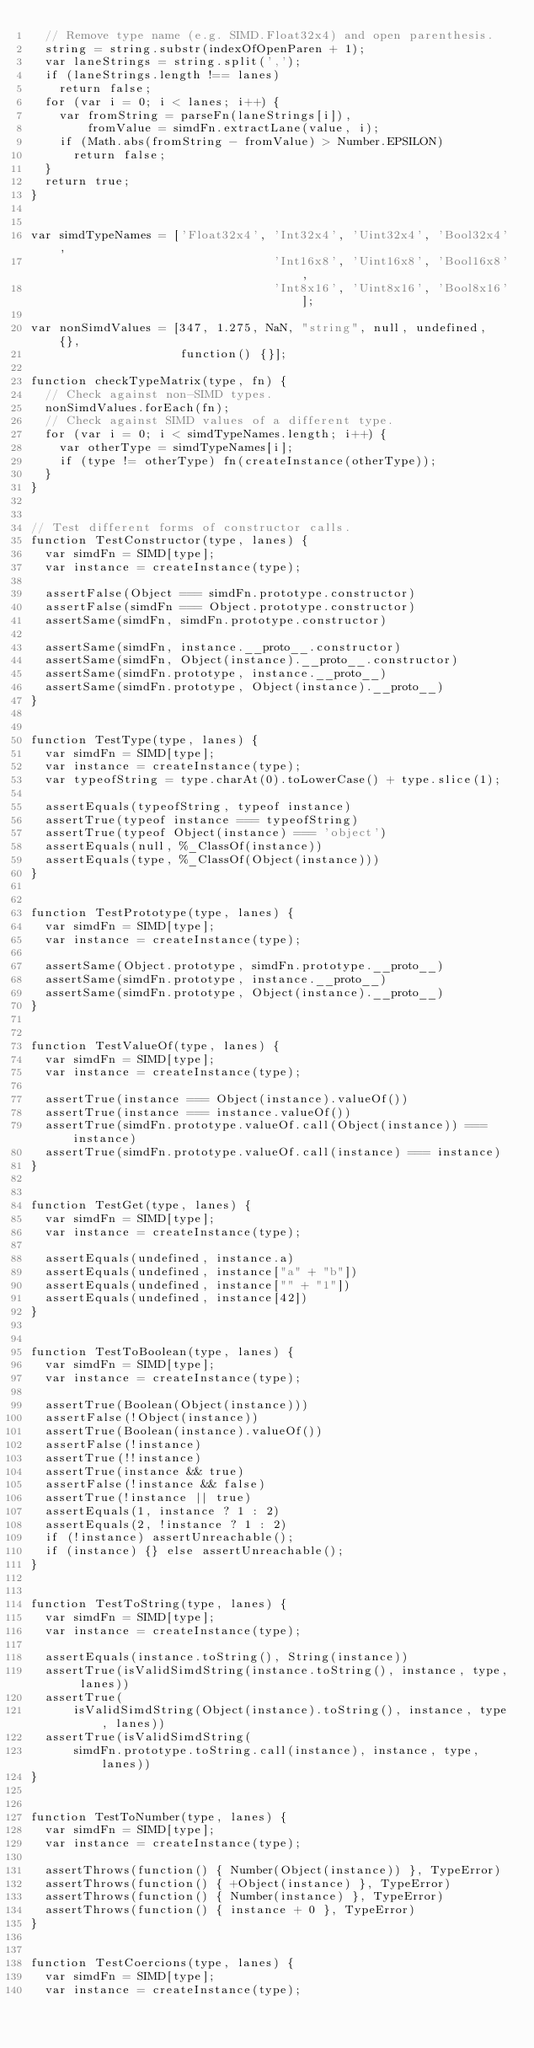Convert code to text. <code><loc_0><loc_0><loc_500><loc_500><_JavaScript_>  // Remove type name (e.g. SIMD.Float32x4) and open parenthesis.
  string = string.substr(indexOfOpenParen + 1);
  var laneStrings = string.split(',');
  if (laneStrings.length !== lanes)
    return false;
  for (var i = 0; i < lanes; i++) {
    var fromString = parseFn(laneStrings[i]),
        fromValue = simdFn.extractLane(value, i);
    if (Math.abs(fromString - fromValue) > Number.EPSILON)
      return false;
  }
  return true;
}


var simdTypeNames = ['Float32x4', 'Int32x4', 'Uint32x4', 'Bool32x4',
                                  'Int16x8', 'Uint16x8', 'Bool16x8',
                                  'Int8x16', 'Uint8x16', 'Bool8x16'];

var nonSimdValues = [347, 1.275, NaN, "string", null, undefined, {},
                     function() {}];

function checkTypeMatrix(type, fn) {
  // Check against non-SIMD types.
  nonSimdValues.forEach(fn);
  // Check against SIMD values of a different type.
  for (var i = 0; i < simdTypeNames.length; i++) {
    var otherType = simdTypeNames[i];
    if (type != otherType) fn(createInstance(otherType));
  }
}


// Test different forms of constructor calls.
function TestConstructor(type, lanes) {
  var simdFn = SIMD[type];
  var instance = createInstance(type);

  assertFalse(Object === simdFn.prototype.constructor)
  assertFalse(simdFn === Object.prototype.constructor)
  assertSame(simdFn, simdFn.prototype.constructor)

  assertSame(simdFn, instance.__proto__.constructor)
  assertSame(simdFn, Object(instance).__proto__.constructor)
  assertSame(simdFn.prototype, instance.__proto__)
  assertSame(simdFn.prototype, Object(instance).__proto__)
}


function TestType(type, lanes) {
  var simdFn = SIMD[type];
  var instance = createInstance(type);
  var typeofString = type.charAt(0).toLowerCase() + type.slice(1);

  assertEquals(typeofString, typeof instance)
  assertTrue(typeof instance === typeofString)
  assertTrue(typeof Object(instance) === 'object')
  assertEquals(null, %_ClassOf(instance))
  assertEquals(type, %_ClassOf(Object(instance)))
}


function TestPrototype(type, lanes) {
  var simdFn = SIMD[type];
  var instance = createInstance(type);

  assertSame(Object.prototype, simdFn.prototype.__proto__)
  assertSame(simdFn.prototype, instance.__proto__)
  assertSame(simdFn.prototype, Object(instance).__proto__)
}


function TestValueOf(type, lanes) {
  var simdFn = SIMD[type];
  var instance = createInstance(type);

  assertTrue(instance === Object(instance).valueOf())
  assertTrue(instance === instance.valueOf())
  assertTrue(simdFn.prototype.valueOf.call(Object(instance)) === instance)
  assertTrue(simdFn.prototype.valueOf.call(instance) === instance)
}


function TestGet(type, lanes) {
  var simdFn = SIMD[type];
  var instance = createInstance(type);

  assertEquals(undefined, instance.a)
  assertEquals(undefined, instance["a" + "b"])
  assertEquals(undefined, instance["" + "1"])
  assertEquals(undefined, instance[42])
}


function TestToBoolean(type, lanes) {
  var simdFn = SIMD[type];
  var instance = createInstance(type);

  assertTrue(Boolean(Object(instance)))
  assertFalse(!Object(instance))
  assertTrue(Boolean(instance).valueOf())
  assertFalse(!instance)
  assertTrue(!!instance)
  assertTrue(instance && true)
  assertFalse(!instance && false)
  assertTrue(!instance || true)
  assertEquals(1, instance ? 1 : 2)
  assertEquals(2, !instance ? 1 : 2)
  if (!instance) assertUnreachable();
  if (instance) {} else assertUnreachable();
}


function TestToString(type, lanes) {
  var simdFn = SIMD[type];
  var instance = createInstance(type);

  assertEquals(instance.toString(), String(instance))
  assertTrue(isValidSimdString(instance.toString(), instance, type, lanes))
  assertTrue(
      isValidSimdString(Object(instance).toString(), instance, type, lanes))
  assertTrue(isValidSimdString(
      simdFn.prototype.toString.call(instance), instance, type, lanes))
}


function TestToNumber(type, lanes) {
  var simdFn = SIMD[type];
  var instance = createInstance(type);

  assertThrows(function() { Number(Object(instance)) }, TypeError)
  assertThrows(function() { +Object(instance) }, TypeError)
  assertThrows(function() { Number(instance) }, TypeError)
  assertThrows(function() { instance + 0 }, TypeError)
}


function TestCoercions(type, lanes) {
  var simdFn = SIMD[type];
  var instance = createInstance(type);</code> 